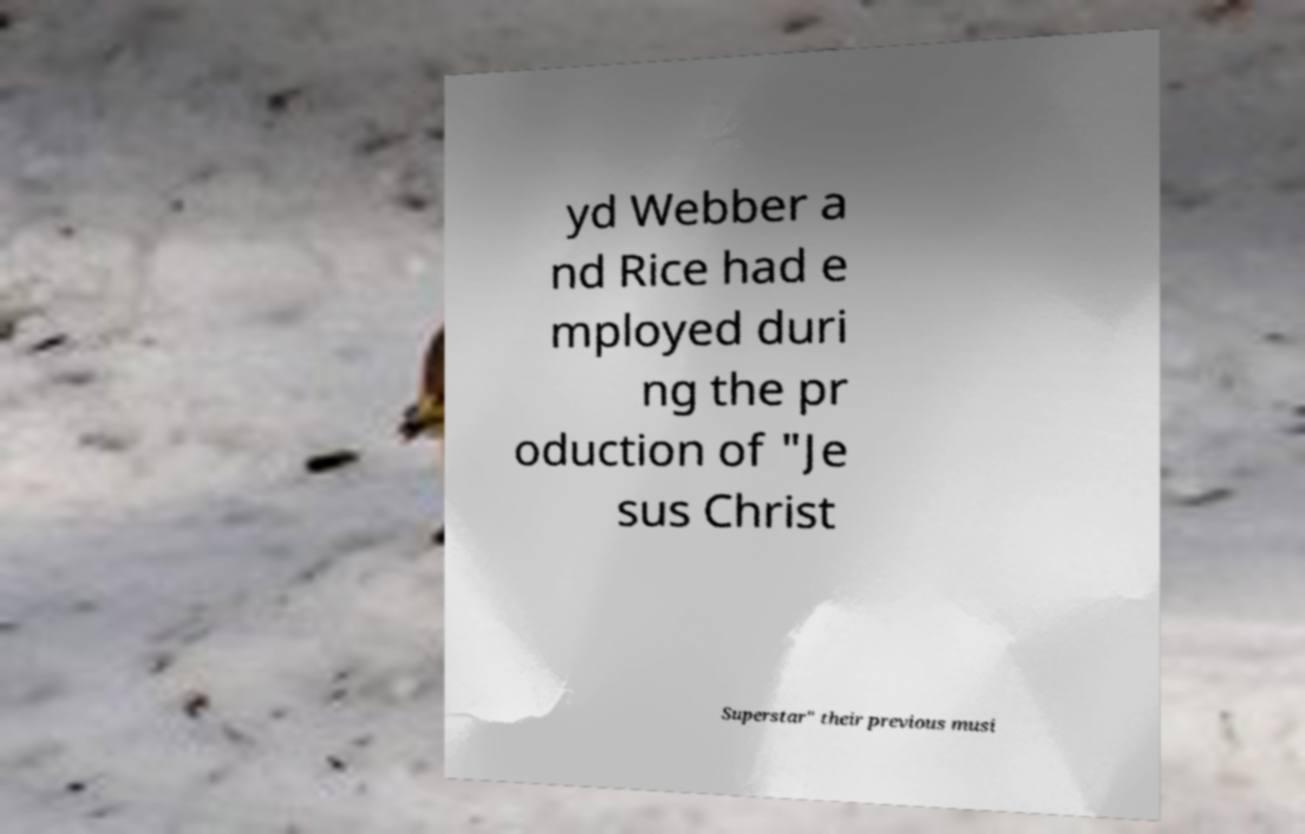There's text embedded in this image that I need extracted. Can you transcribe it verbatim? yd Webber a nd Rice had e mployed duri ng the pr oduction of "Je sus Christ Superstar" their previous musi 